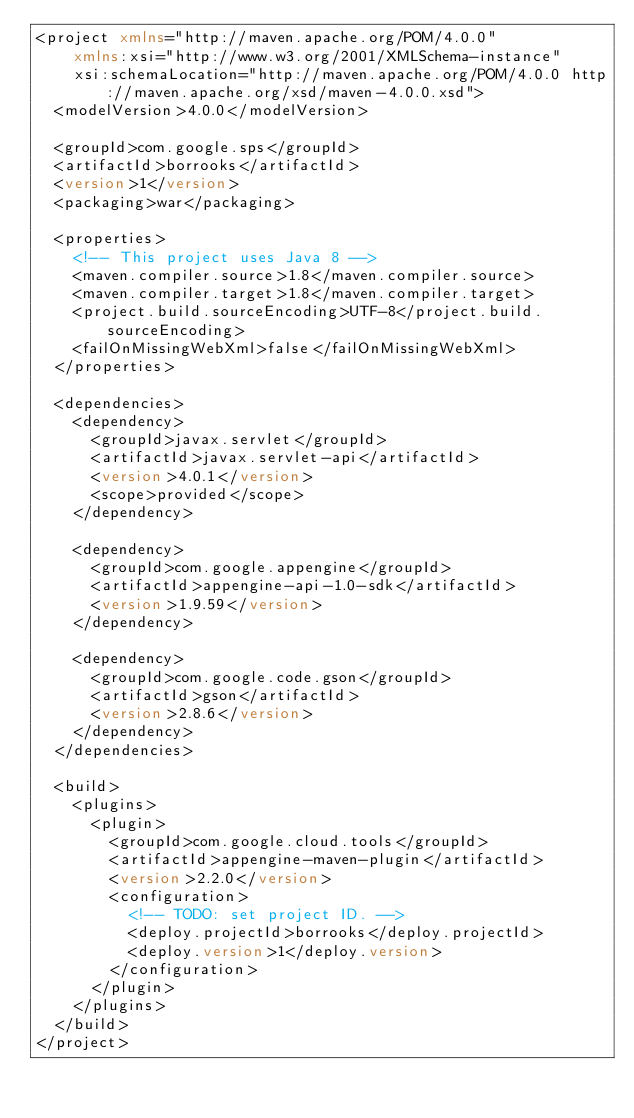Convert code to text. <code><loc_0><loc_0><loc_500><loc_500><_XML_><project xmlns="http://maven.apache.org/POM/4.0.0"
    xmlns:xsi="http://www.w3.org/2001/XMLSchema-instance"
    xsi:schemaLocation="http://maven.apache.org/POM/4.0.0 http://maven.apache.org/xsd/maven-4.0.0.xsd">
  <modelVersion>4.0.0</modelVersion>

  <groupId>com.google.sps</groupId>
  <artifactId>borrooks</artifactId>
  <version>1</version>
  <packaging>war</packaging>

  <properties>
    <!-- This project uses Java 8 -->
    <maven.compiler.source>1.8</maven.compiler.source>
    <maven.compiler.target>1.8</maven.compiler.target>
    <project.build.sourceEncoding>UTF-8</project.build.sourceEncoding>
    <failOnMissingWebXml>false</failOnMissingWebXml>
  </properties>

  <dependencies>
    <dependency>
      <groupId>javax.servlet</groupId>
      <artifactId>javax.servlet-api</artifactId>
      <version>4.0.1</version>
      <scope>provided</scope>
    </dependency>

    <dependency>
      <groupId>com.google.appengine</groupId>
      <artifactId>appengine-api-1.0-sdk</artifactId>
      <version>1.9.59</version>
    </dependency>

    <dependency>
      <groupId>com.google.code.gson</groupId>
      <artifactId>gson</artifactId>
      <version>2.8.6</version>
    </dependency>
  </dependencies>

  <build>
    <plugins>
      <plugin>
        <groupId>com.google.cloud.tools</groupId>
        <artifactId>appengine-maven-plugin</artifactId>
        <version>2.2.0</version>
        <configuration>
          <!-- TODO: set project ID. -->
          <deploy.projectId>borrooks</deploy.projectId>
          <deploy.version>1</deploy.version>
        </configuration>
      </plugin>
    </plugins>
  </build>
</project></code> 